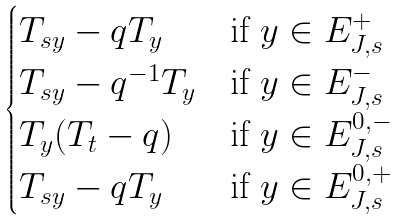Convert formula to latex. <formula><loc_0><loc_0><loc_500><loc_500>\begin{cases} T _ { s y } - q T _ { y } & \text {if $y\in E_{J,s}^{+}$} \\ T _ { s y } - q ^ { - 1 } T _ { y } & \text {if $y\in E_{J,s}^{-}$} \\ T _ { y } ( T _ { t } - q ) & \text {if $y\in E_{J,s}^{0,-}$} \\ T _ { s y } - q T _ { y } & \text {if $y\in E_{J,s}^{0,+}$} \\ \end{cases}</formula> 